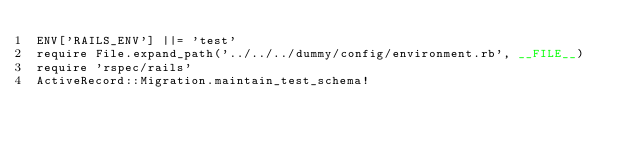Convert code to text. <code><loc_0><loc_0><loc_500><loc_500><_Ruby_>ENV['RAILS_ENV'] ||= 'test'
require File.expand_path('../../../dummy/config/environment.rb', __FILE__)
require 'rspec/rails'
ActiveRecord::Migration.maintain_test_schema!
</code> 